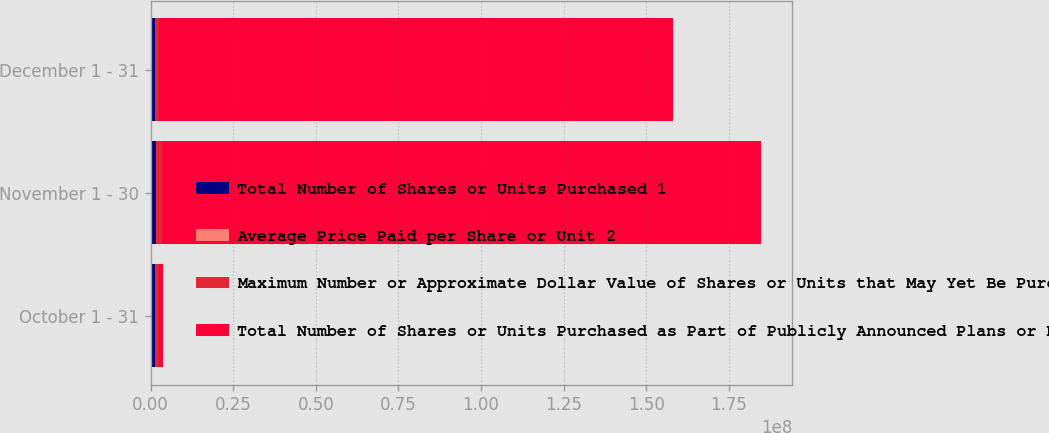Convert chart. <chart><loc_0><loc_0><loc_500><loc_500><stacked_bar_chart><ecel><fcel>October 1 - 31<fcel>November 1 - 30<fcel>December 1 - 31<nl><fcel>Total Number of Shares or Units Purchased 1<fcel>1.23187e+06<fcel>1.72314e+06<fcel>1.29564e+06<nl><fcel>Average Price Paid per Share or Unit 2<fcel>20.74<fcel>18.89<fcel>20.25<nl><fcel>Maximum Number or Approximate Dollar Value of Shares or Units that May Yet Be Purchased Under the Plans or Programs 3<fcel>1.23039e+06<fcel>1.72225e+06<fcel>1.285e+06<nl><fcel>Total Number of Shares or Units Purchased as Part of Publicly Announced Plans or Programs 3<fcel>1.285e+06<fcel>1.81475e+08<fcel>1.5546e+08<nl></chart> 